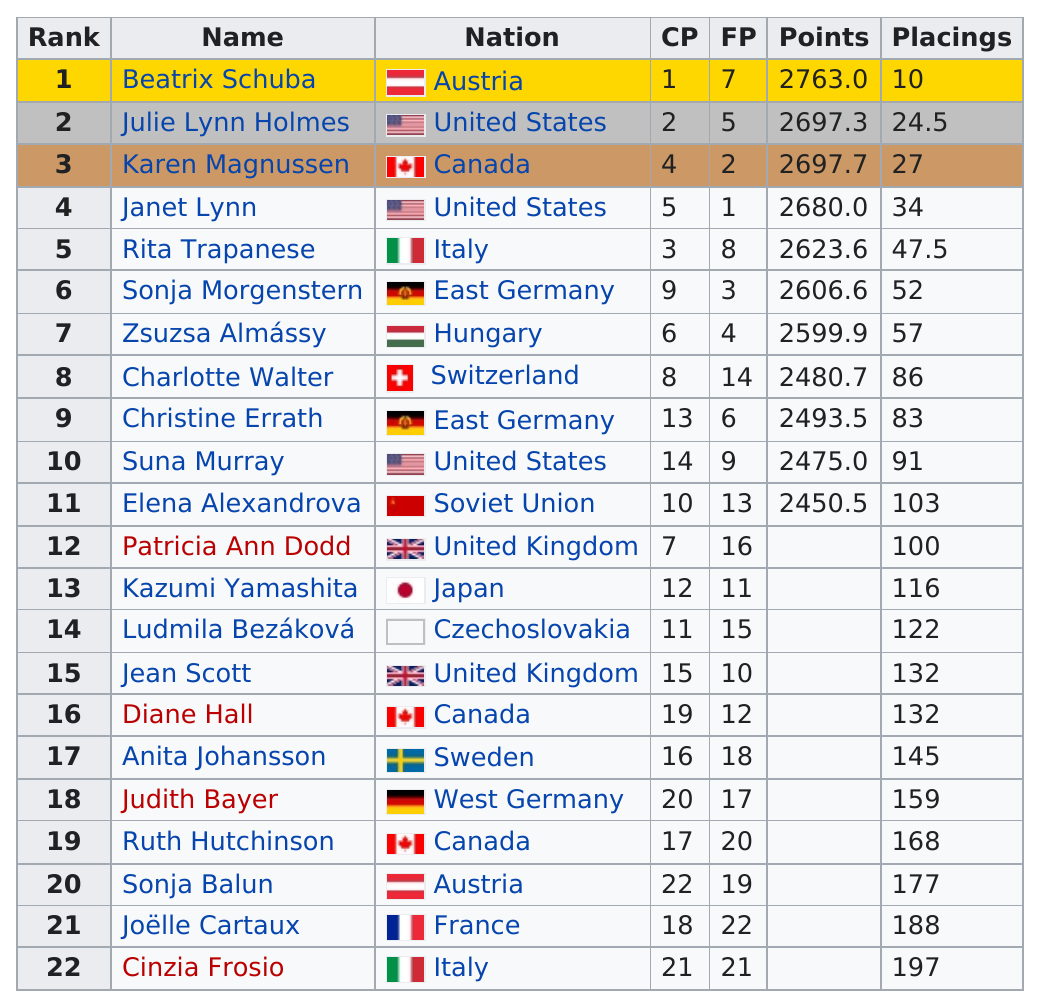Highlight a few significant elements in this photo. Elena Alexandrova received the lowest number of points among all the competitors. Six skaters have a total point value of at most 2600. The United States appears three times in the "Nations" column. Kazumi Yamashita was the only woman from Japan to compete in the 1971 World Figure Skating Championships. There is a competitor who scored more than 2600 points and is from Canada. Their name is Karen Magnussen. 